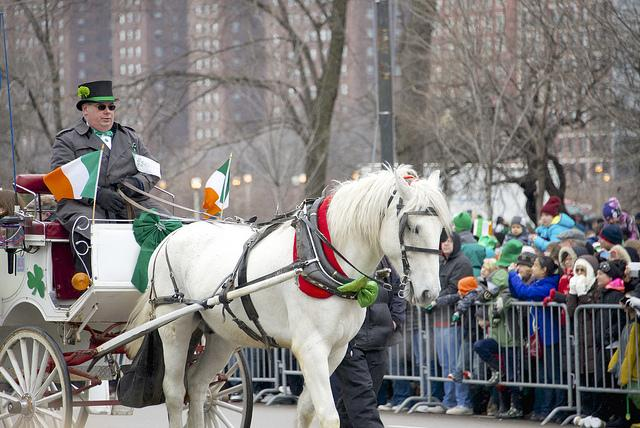What country's flag is on the white carriage? ireland 